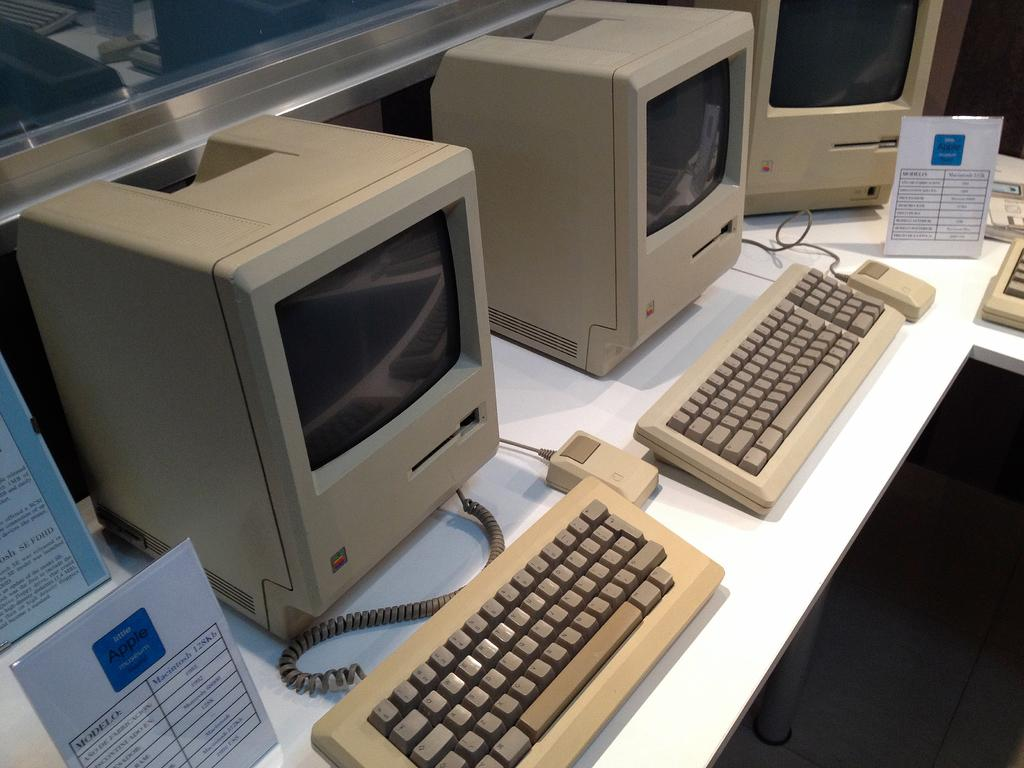Provide a one-sentence caption for the provided image. Old desktop next to a sign taht says Macintosh 128kb. 